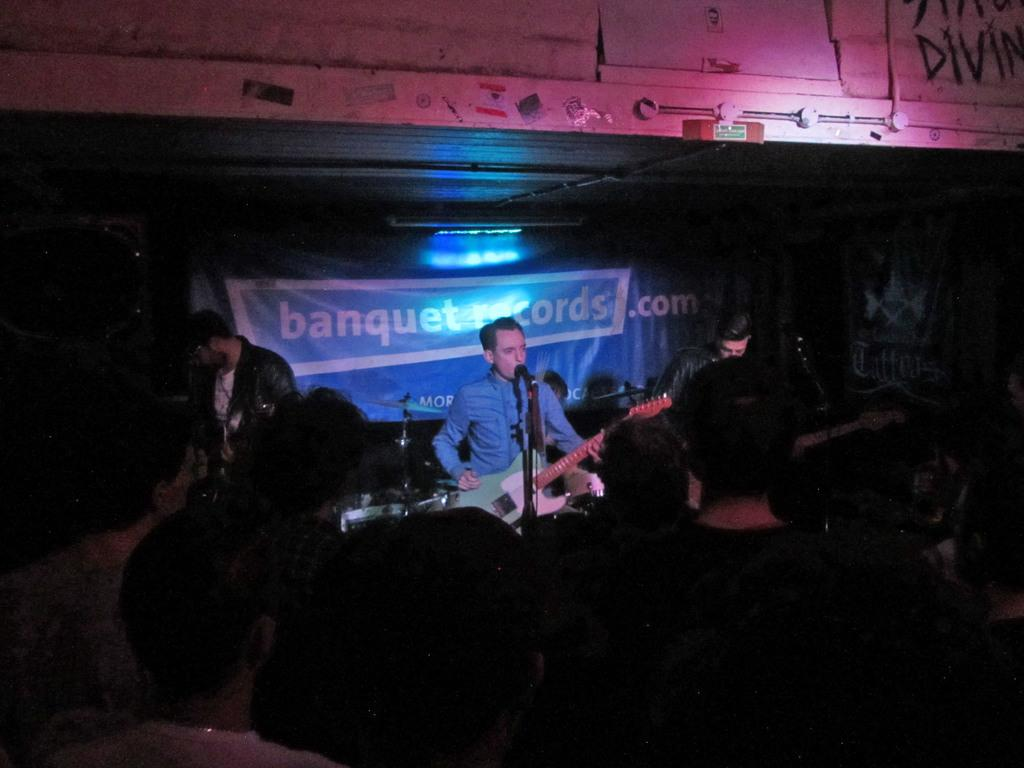What are the people in the image doing? The people in the image are playing a musical instrument. What can be seen in the background of the image? There is a banner and lights in the background of the image. What type of education is being taught in the image? There is no indication of any educational activity in the image; it features people playing a musical instrument. What emotions are the women in the image displaying? There is no reference to any women or their emotions in the image; it only shows people playing a musical instrument. 